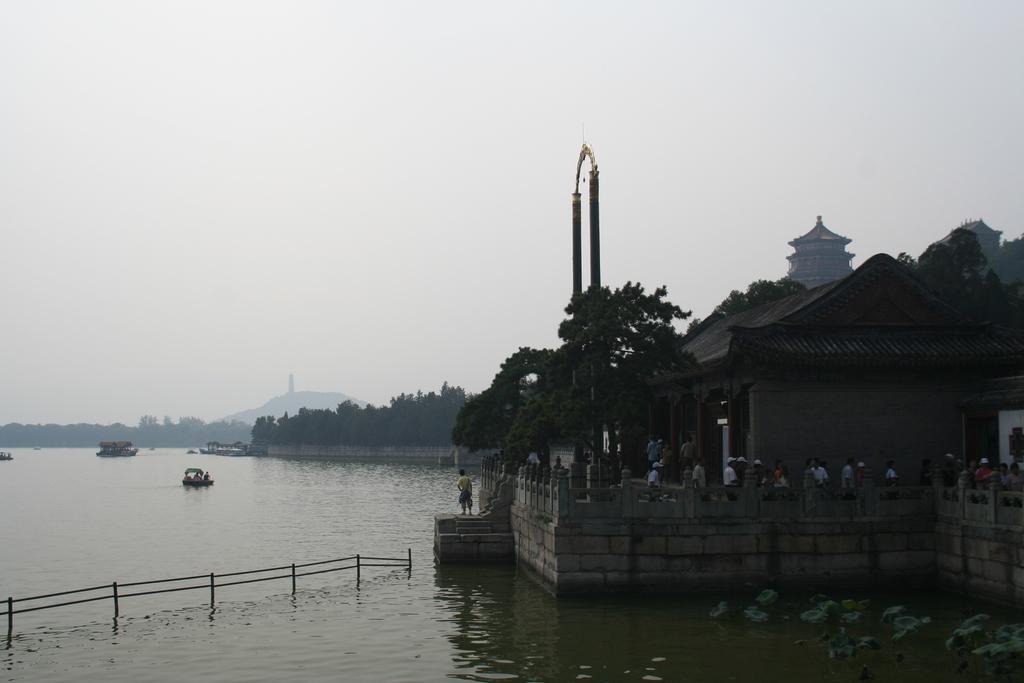Could you give a brief overview of what you see in this image? This is an outside view. On the left side there are few boats on the water. On the right side there are many trees and buildings. Here I can see many people are standing. In the middle of the image there is an arch. At the top of the image I can see the sky. In the bottom left-hand corner there is a railing in the water. 